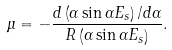<formula> <loc_0><loc_0><loc_500><loc_500>\mu = - \frac { d \left ( \alpha \sin \alpha E _ { s } \right ) / d \alpha } { R \left ( \alpha \sin \alpha E _ { s } \right ) } .</formula> 